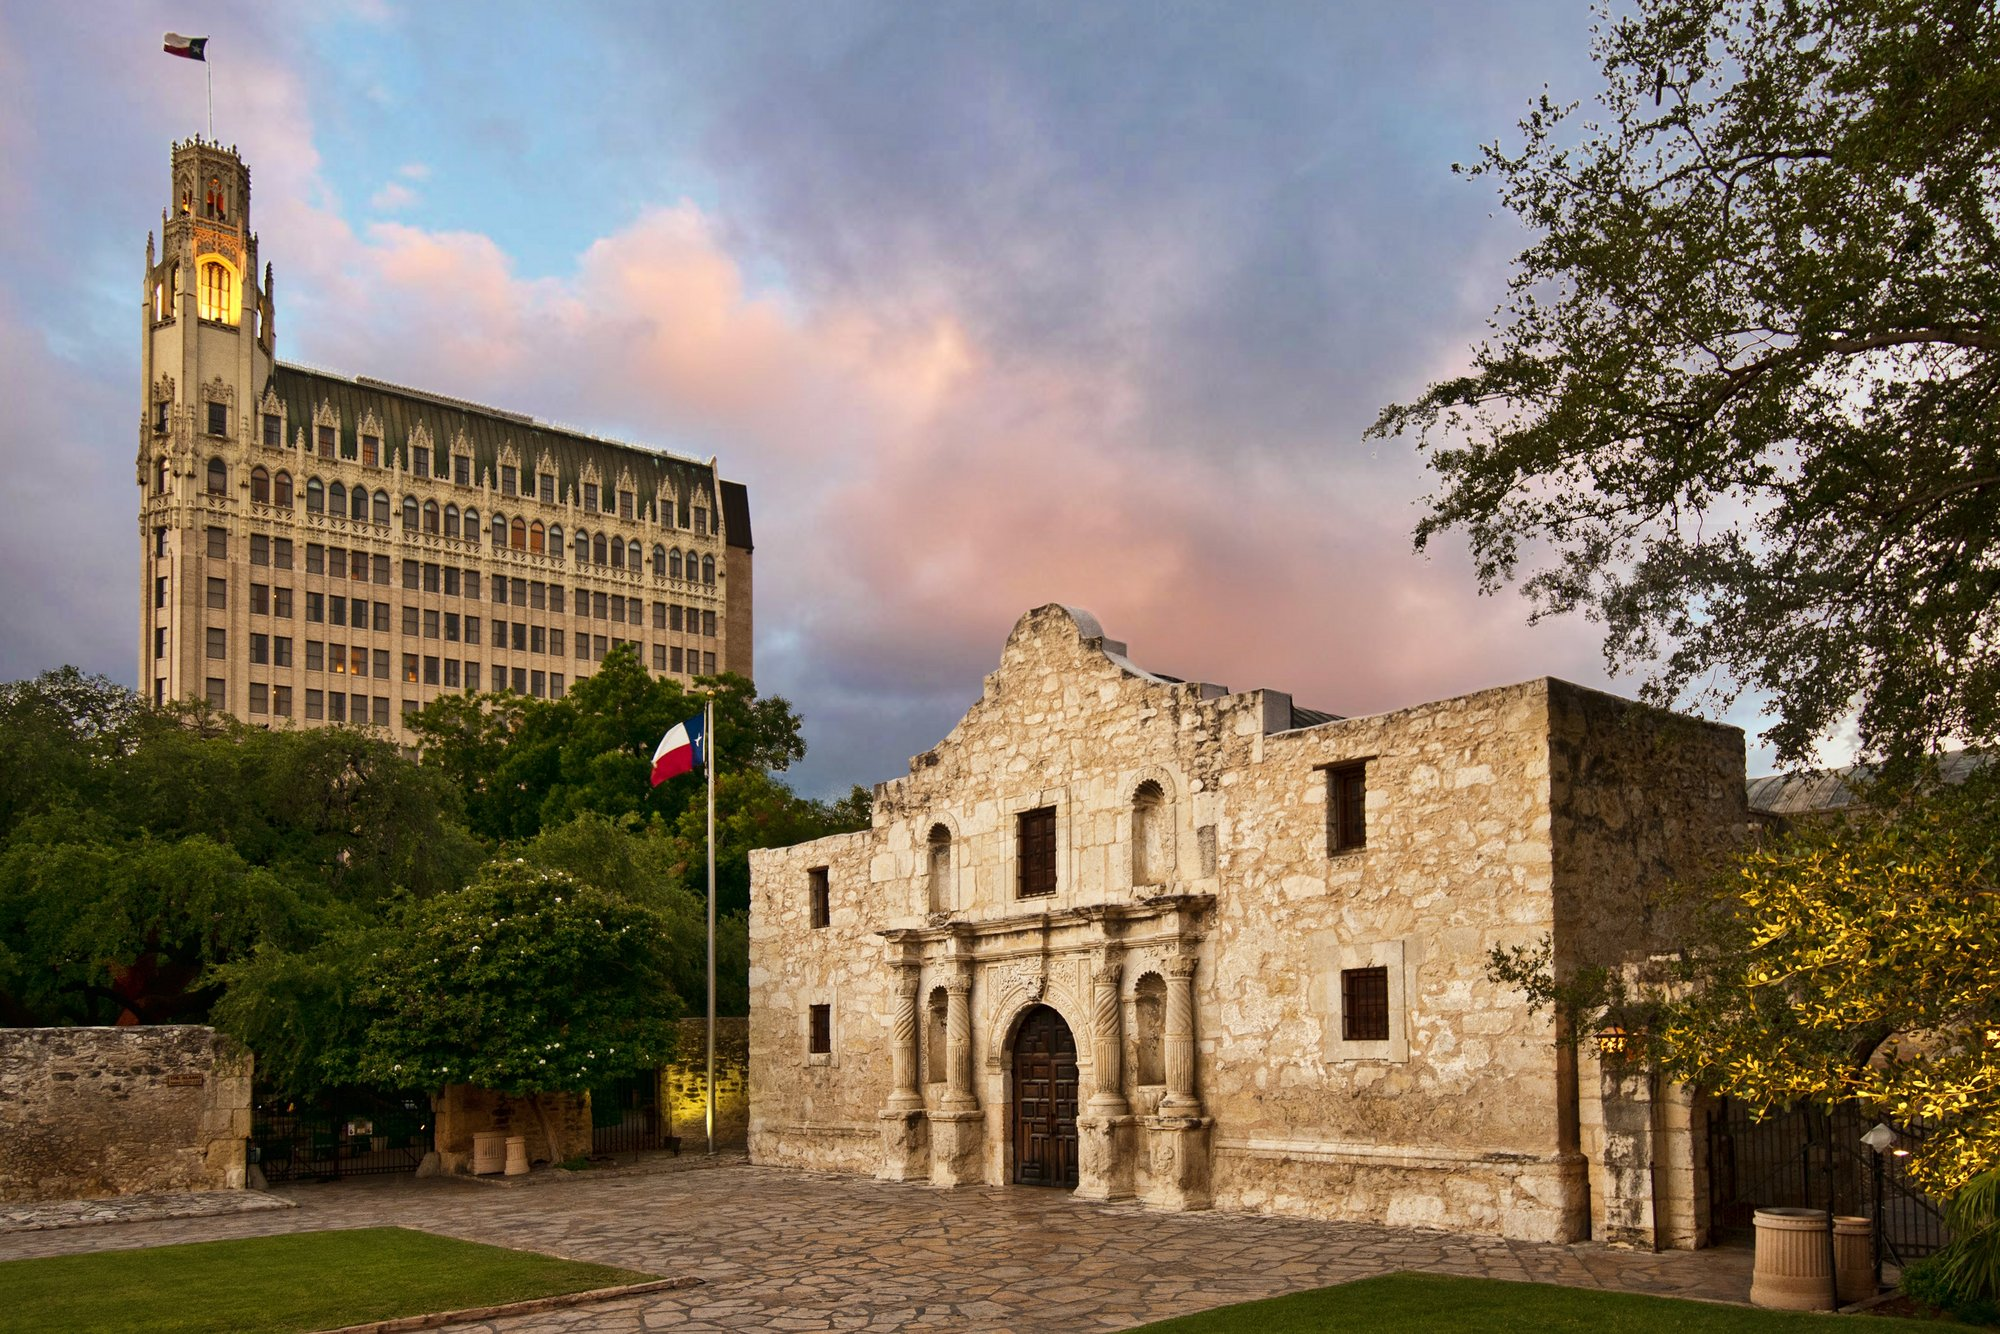Imagine a Scavenger Hunt happening in the area surrounding the Alamo. What are some possible clues and tasks to include? Sure! Here are some creative scavenger hunt clues and tasks: 

1. **Clue**: 'Find the building where history stands tall, with a flag proudly waving beside it.' - **Task**: Take a selfie in front of the Alamo.
2. **Clue**: 'Look for the mighty oak near the historic stone.' - **Task**: Find a large tree nearby and collect a fallen leaf.
3. **Clue**: 'This tall building keeps time and offers a stunning view of history.' - **Task**: Snap a photo of the clock tower in the modern building behind the Alamo.
4. **Clue**: 'A place where battles were fought, and legends were born, now marked with carvings in stone.' - **Task**: Sketch or take a close-up picture of the detailed carvings on the Alamo's facade.
5. **Clue**: 'A banner that holds the colors of the lone star state.' - **Task**: Identify the colors on the Texas flag flying near the Alamo and describe their significance. 